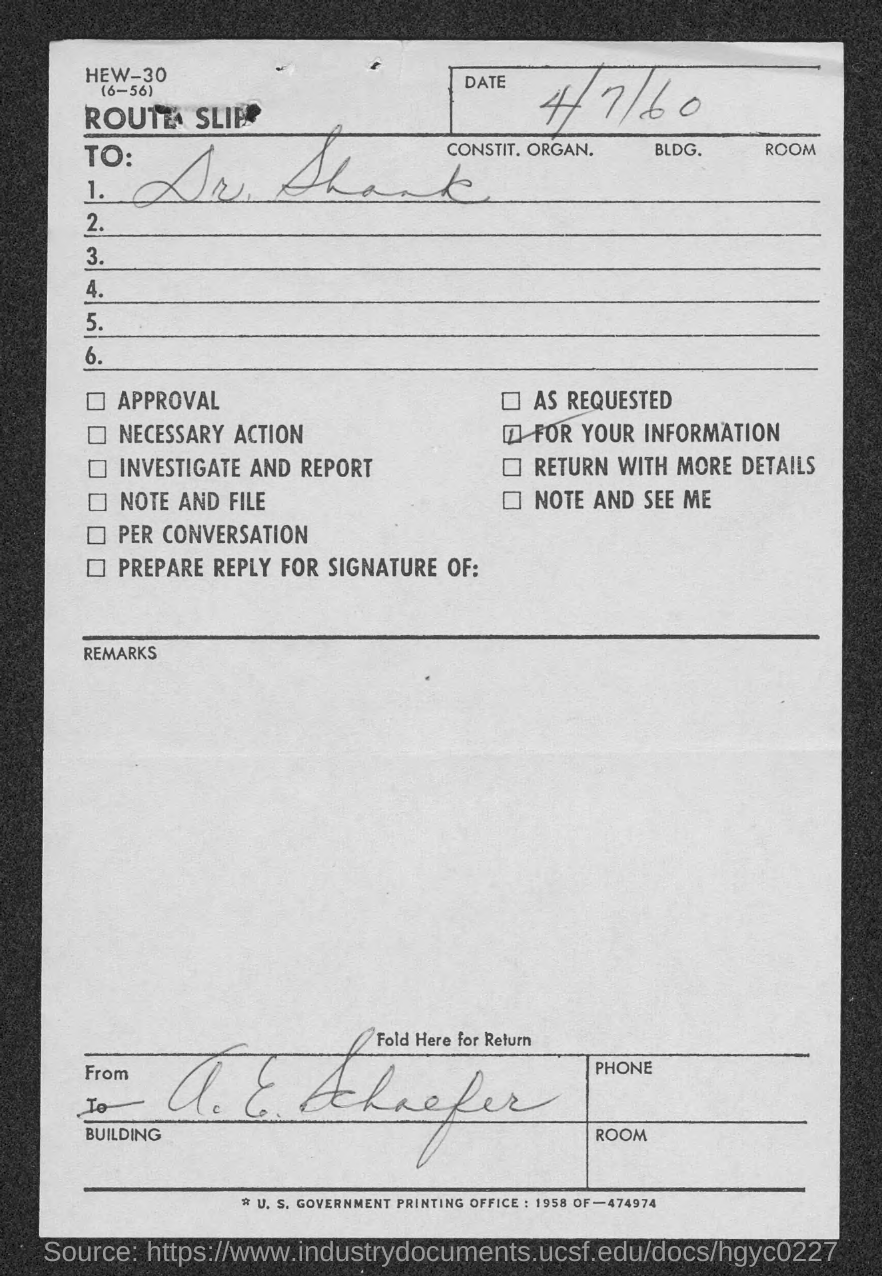What is the date mentioned in the route slip?
Provide a short and direct response. 4/7/60. To whom, the route slip is addressed?
Provide a succinct answer. Dr. Shank. 